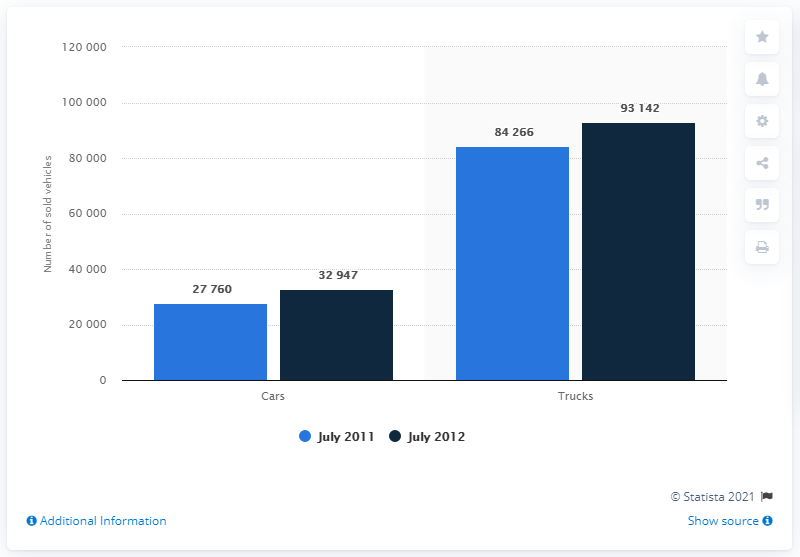Outline some significant characteristics in this image. The two largest bars on the x axis are referred to as trucks. In July 2012, the ratio of sales between cars and trucks was 0.35373... 